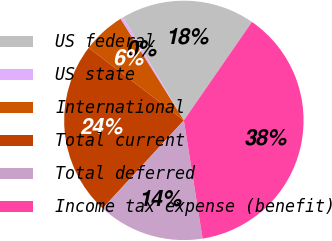Convert chart to OTSL. <chart><loc_0><loc_0><loc_500><loc_500><pie_chart><fcel>US federal<fcel>US state<fcel>International<fcel>Total current<fcel>Total deferred<fcel>Income tax expense (benefit)<nl><fcel>18.11%<fcel>0.4%<fcel>5.75%<fcel>23.51%<fcel>14.36%<fcel>37.87%<nl></chart> 